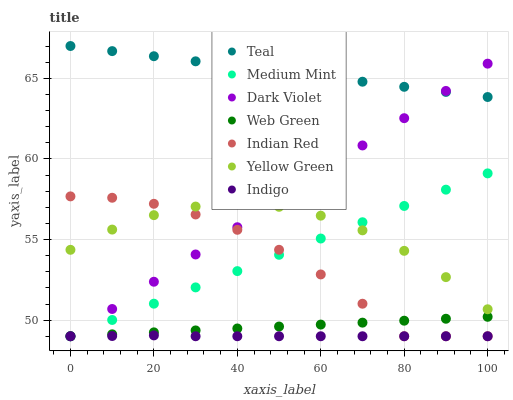Does Indigo have the minimum area under the curve?
Answer yes or no. Yes. Does Teal have the maximum area under the curve?
Answer yes or no. Yes. Does Teal have the minimum area under the curve?
Answer yes or no. No. Does Indigo have the maximum area under the curve?
Answer yes or no. No. Is Teal the smoothest?
Answer yes or no. Yes. Is Indian Red the roughest?
Answer yes or no. Yes. Is Indigo the smoothest?
Answer yes or no. No. Is Indigo the roughest?
Answer yes or no. No. Does Medium Mint have the lowest value?
Answer yes or no. Yes. Does Teal have the lowest value?
Answer yes or no. No. Does Teal have the highest value?
Answer yes or no. Yes. Does Indigo have the highest value?
Answer yes or no. No. Is Medium Mint less than Teal?
Answer yes or no. Yes. Is Teal greater than Indian Red?
Answer yes or no. Yes. Does Indigo intersect Indian Red?
Answer yes or no. Yes. Is Indigo less than Indian Red?
Answer yes or no. No. Is Indigo greater than Indian Red?
Answer yes or no. No. Does Medium Mint intersect Teal?
Answer yes or no. No. 